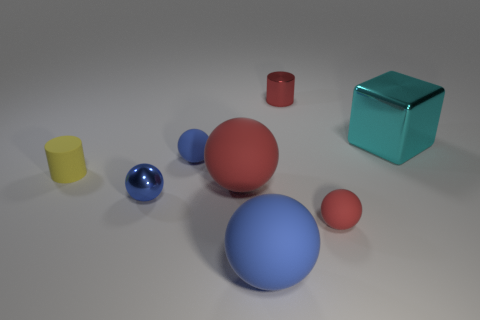Are there any big rubber objects in front of the small red sphere?
Provide a succinct answer. Yes. There is a rubber object that is left of the blue metallic ball; does it have the same size as the metallic thing that is left of the big blue thing?
Your response must be concise. Yes. Is there a brown metallic object of the same size as the red cylinder?
Provide a short and direct response. No. There is a blue rubber thing that is behind the large red rubber object; does it have the same shape as the big cyan object?
Your response must be concise. No. What is the material of the tiny red object behind the small blue rubber ball?
Give a very brief answer. Metal. There is a large rubber object that is behind the tiny red object in front of the small yellow rubber thing; what is its shape?
Provide a short and direct response. Sphere. There is a blue metal thing; is it the same shape as the red thing left of the small red shiny cylinder?
Offer a terse response. Yes. What number of tiny things are left of the blue matte ball that is in front of the small rubber cylinder?
Ensure brevity in your answer.  3. There is another large object that is the same shape as the large red rubber thing; what material is it?
Keep it short and to the point. Rubber. How many red objects are matte cylinders or matte things?
Offer a terse response. 2. 